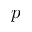Convert formula to latex. <formula><loc_0><loc_0><loc_500><loc_500>p</formula> 